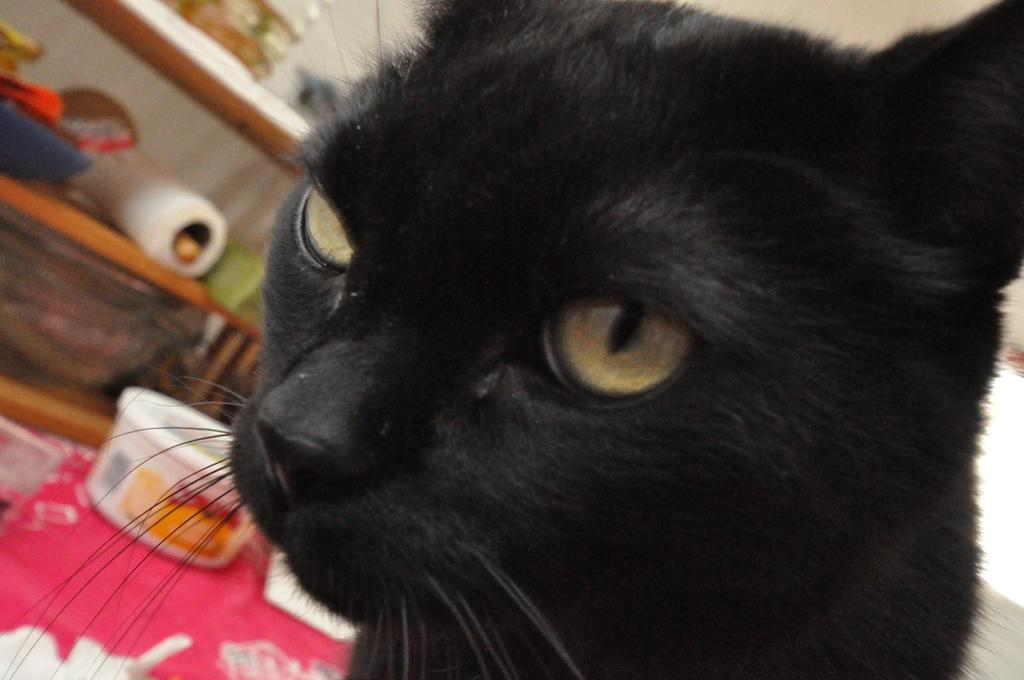What type of animal is in the image? There is a black cat in the image. Where is the cat located in the image? The cat is on the front of the image. What can be seen on the left side of the image? There are shelves on the left side of the image. What is on the shelves? There are various items on the shelves. What color is the leaf on the cat's tail in the image? There is no leaf present in the image, and the cat's tail is not visible. 